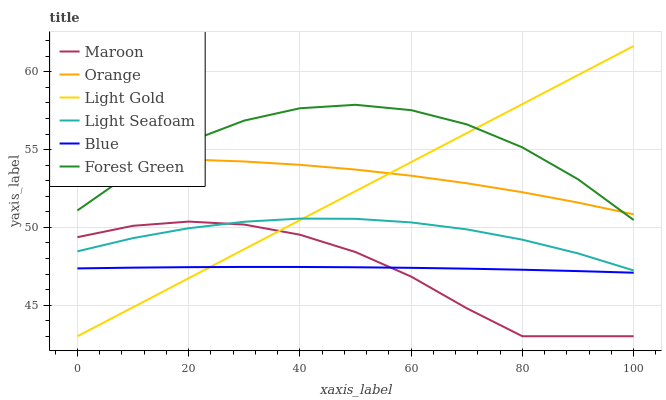Does Maroon have the minimum area under the curve?
Answer yes or no. Yes. Does Forest Green have the maximum area under the curve?
Answer yes or no. Yes. Does Forest Green have the minimum area under the curve?
Answer yes or no. No. Does Maroon have the maximum area under the curve?
Answer yes or no. No. Is Light Gold the smoothest?
Answer yes or no. Yes. Is Forest Green the roughest?
Answer yes or no. Yes. Is Maroon the smoothest?
Answer yes or no. No. Is Maroon the roughest?
Answer yes or no. No. Does Maroon have the lowest value?
Answer yes or no. Yes. Does Forest Green have the lowest value?
Answer yes or no. No. Does Light Gold have the highest value?
Answer yes or no. Yes. Does Maroon have the highest value?
Answer yes or no. No. Is Light Seafoam less than Orange?
Answer yes or no. Yes. Is Forest Green greater than Blue?
Answer yes or no. Yes. Does Orange intersect Forest Green?
Answer yes or no. Yes. Is Orange less than Forest Green?
Answer yes or no. No. Is Orange greater than Forest Green?
Answer yes or no. No. Does Light Seafoam intersect Orange?
Answer yes or no. No. 